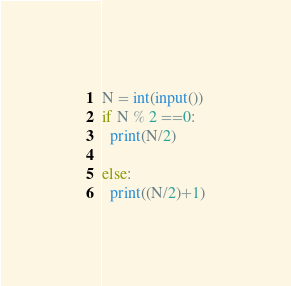<code> <loc_0><loc_0><loc_500><loc_500><_Python_>N = int(input())
if N % 2 ==0:
  print(N/2)

else:
  print((N/2)+1)</code> 